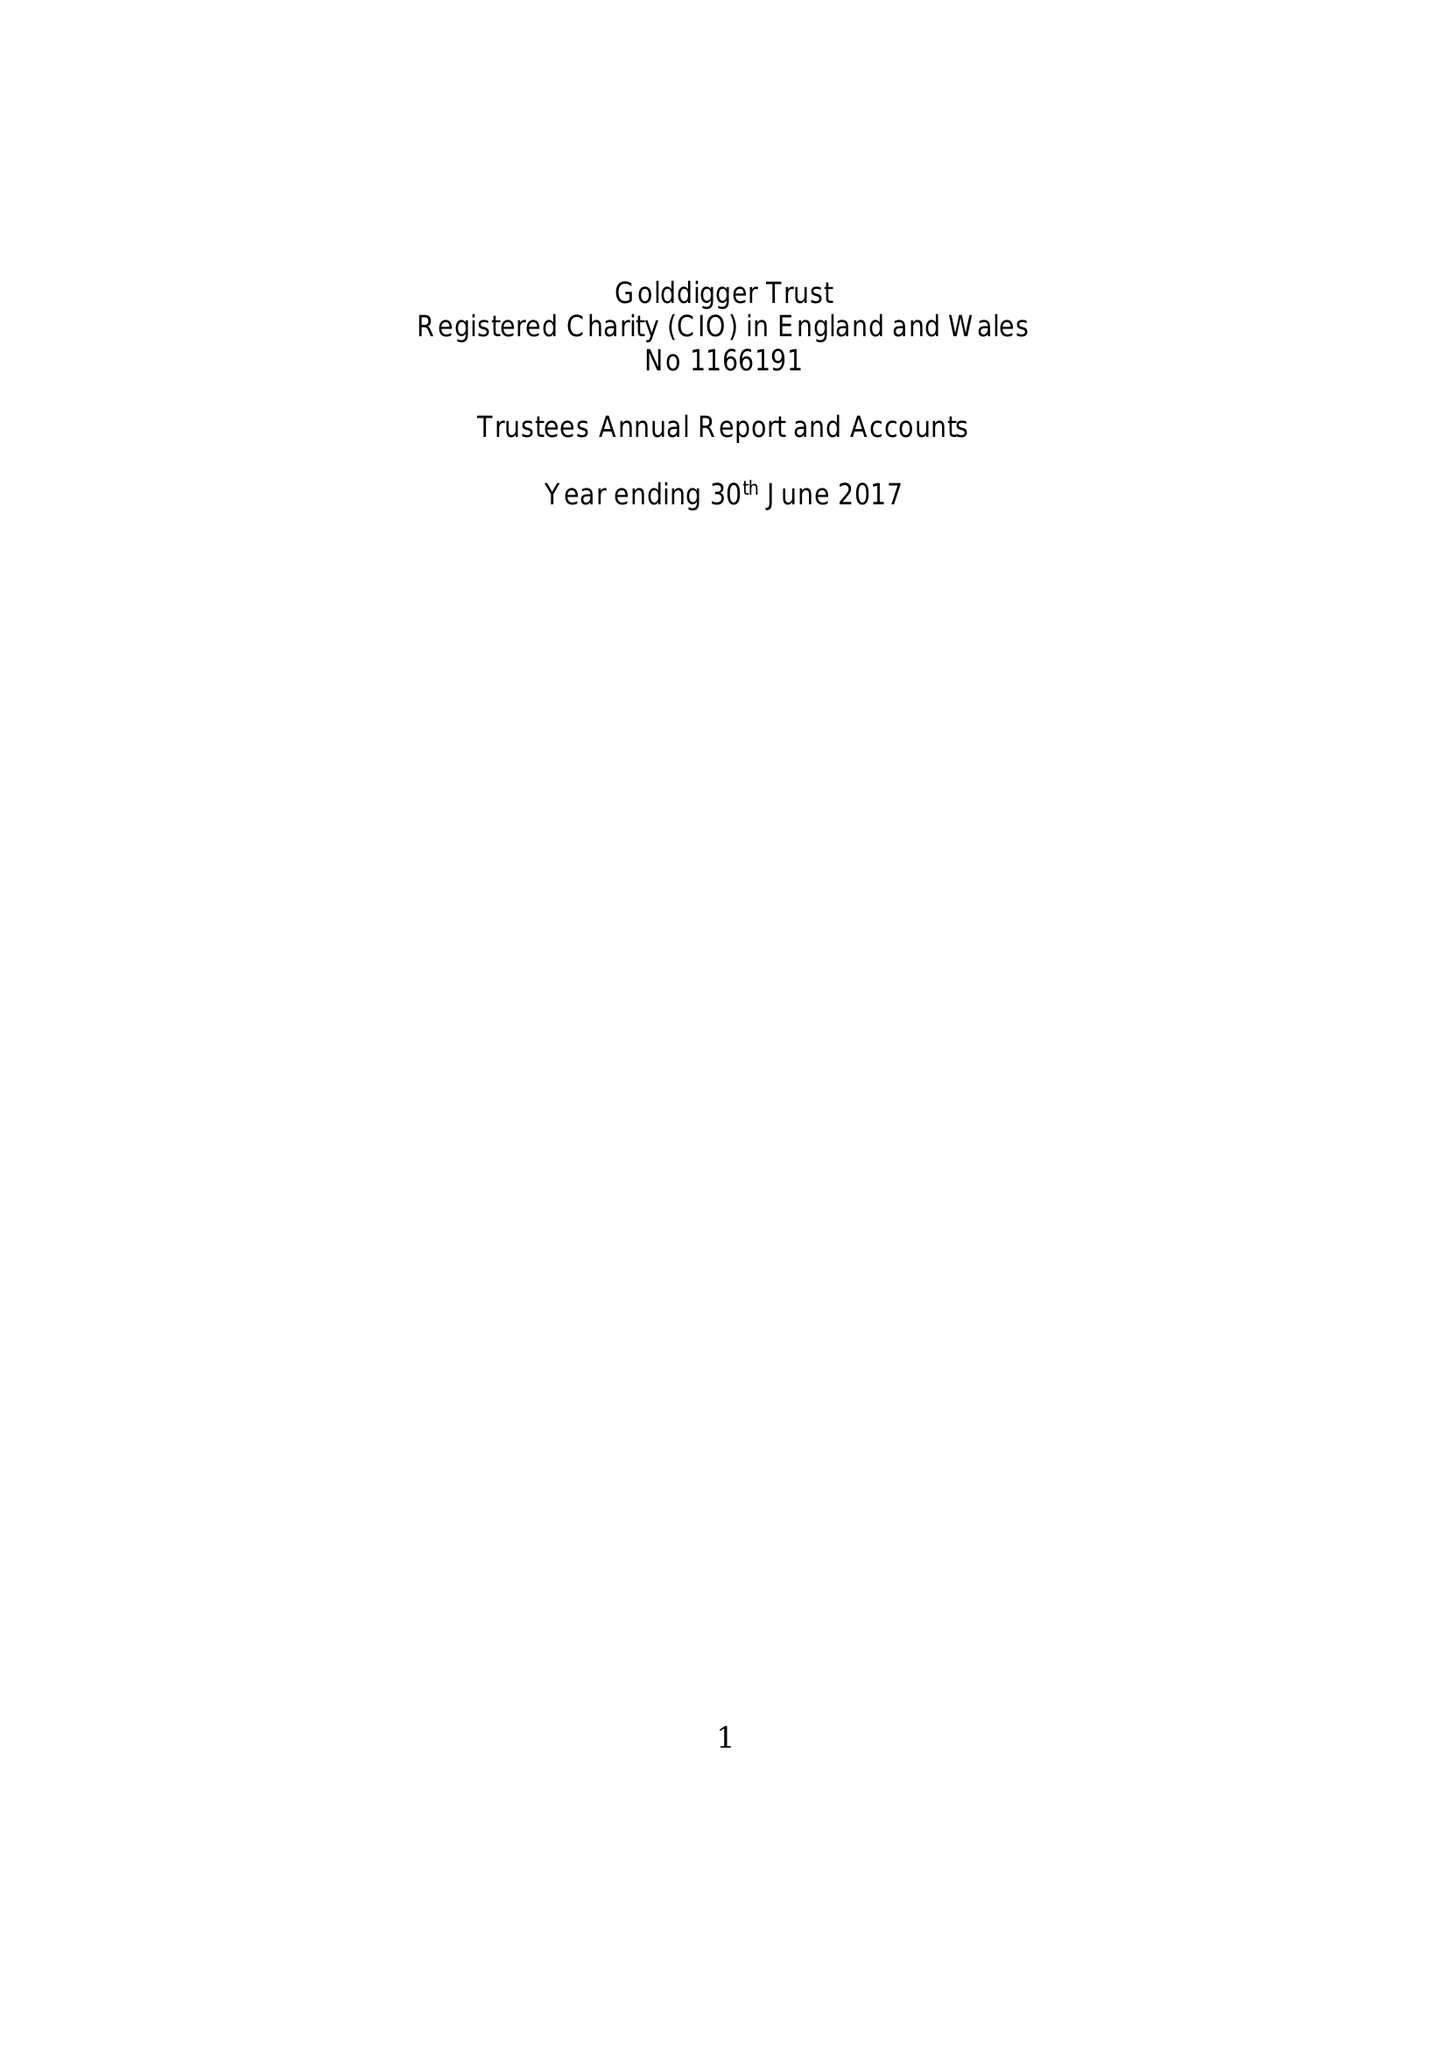What is the value for the address__postcode?
Answer the question using a single word or phrase. S11 8YN 